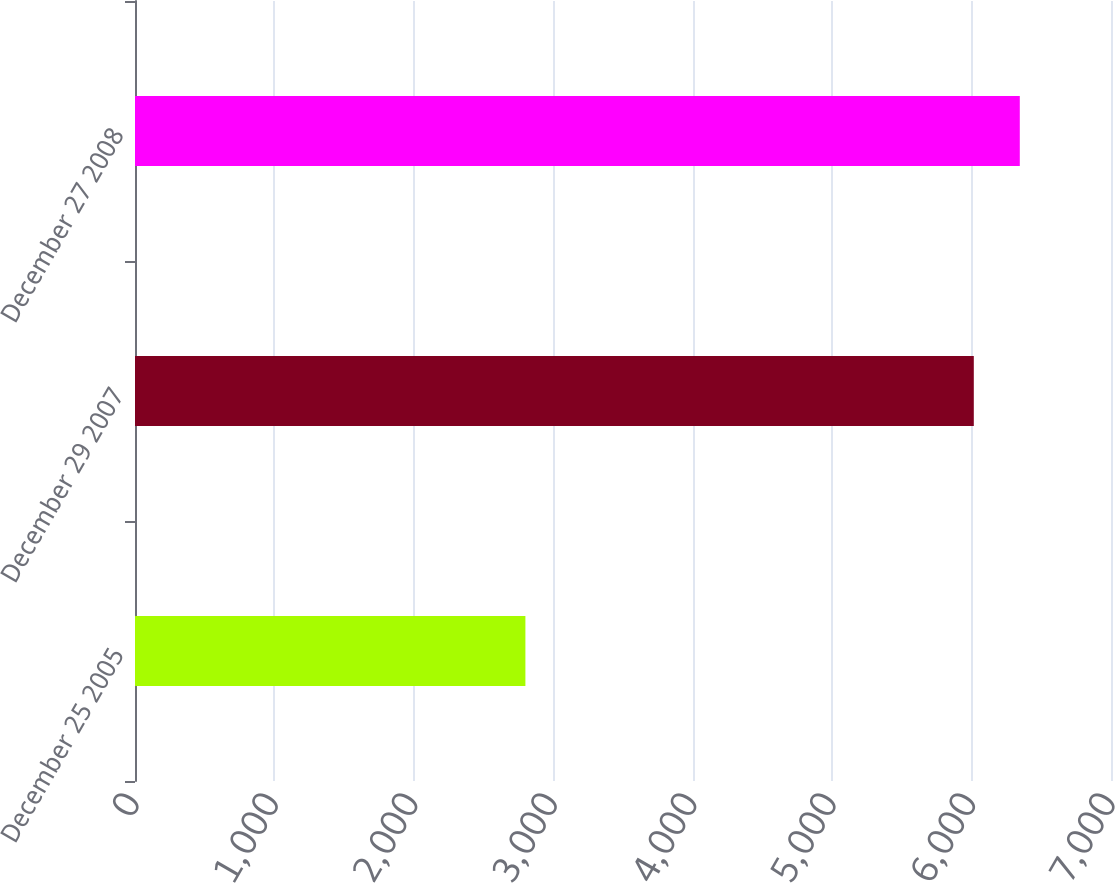Convert chart to OTSL. <chart><loc_0><loc_0><loc_500><loc_500><bar_chart><fcel>December 25 2005<fcel>December 29 2007<fcel>December 27 2008<nl><fcel>2800<fcel>6016<fcel>6345.9<nl></chart> 